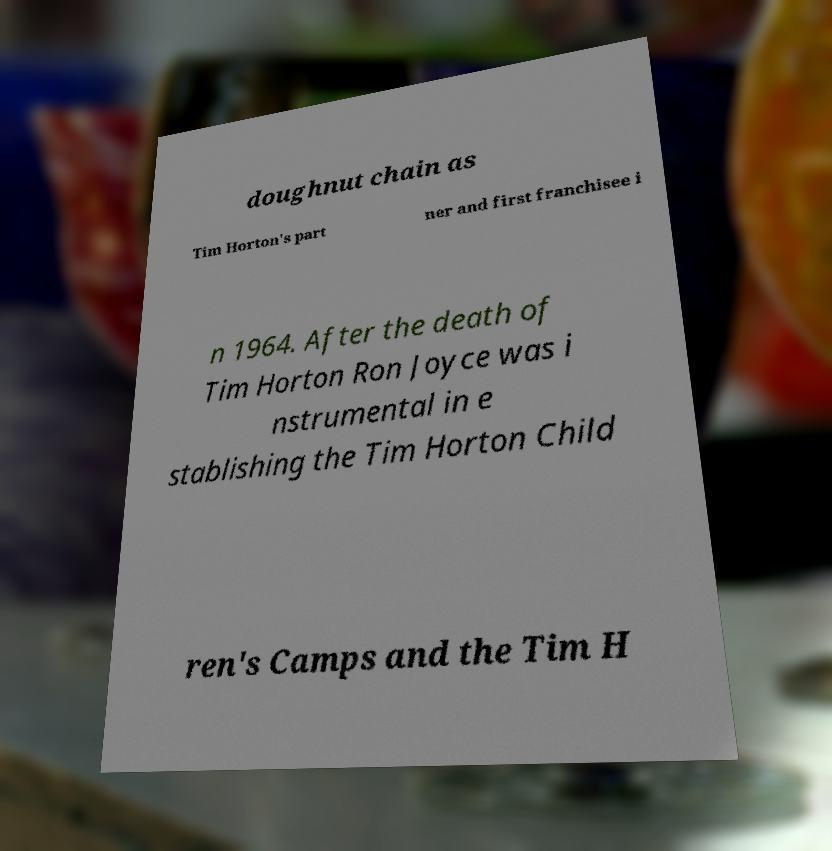There's text embedded in this image that I need extracted. Can you transcribe it verbatim? doughnut chain as Tim Horton's part ner and first franchisee i n 1964. After the death of Tim Horton Ron Joyce was i nstrumental in e stablishing the Tim Horton Child ren's Camps and the Tim H 